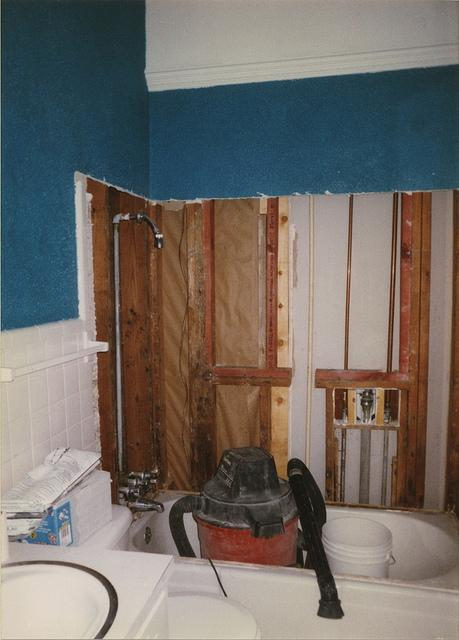Why did they open up the wall? renovation 